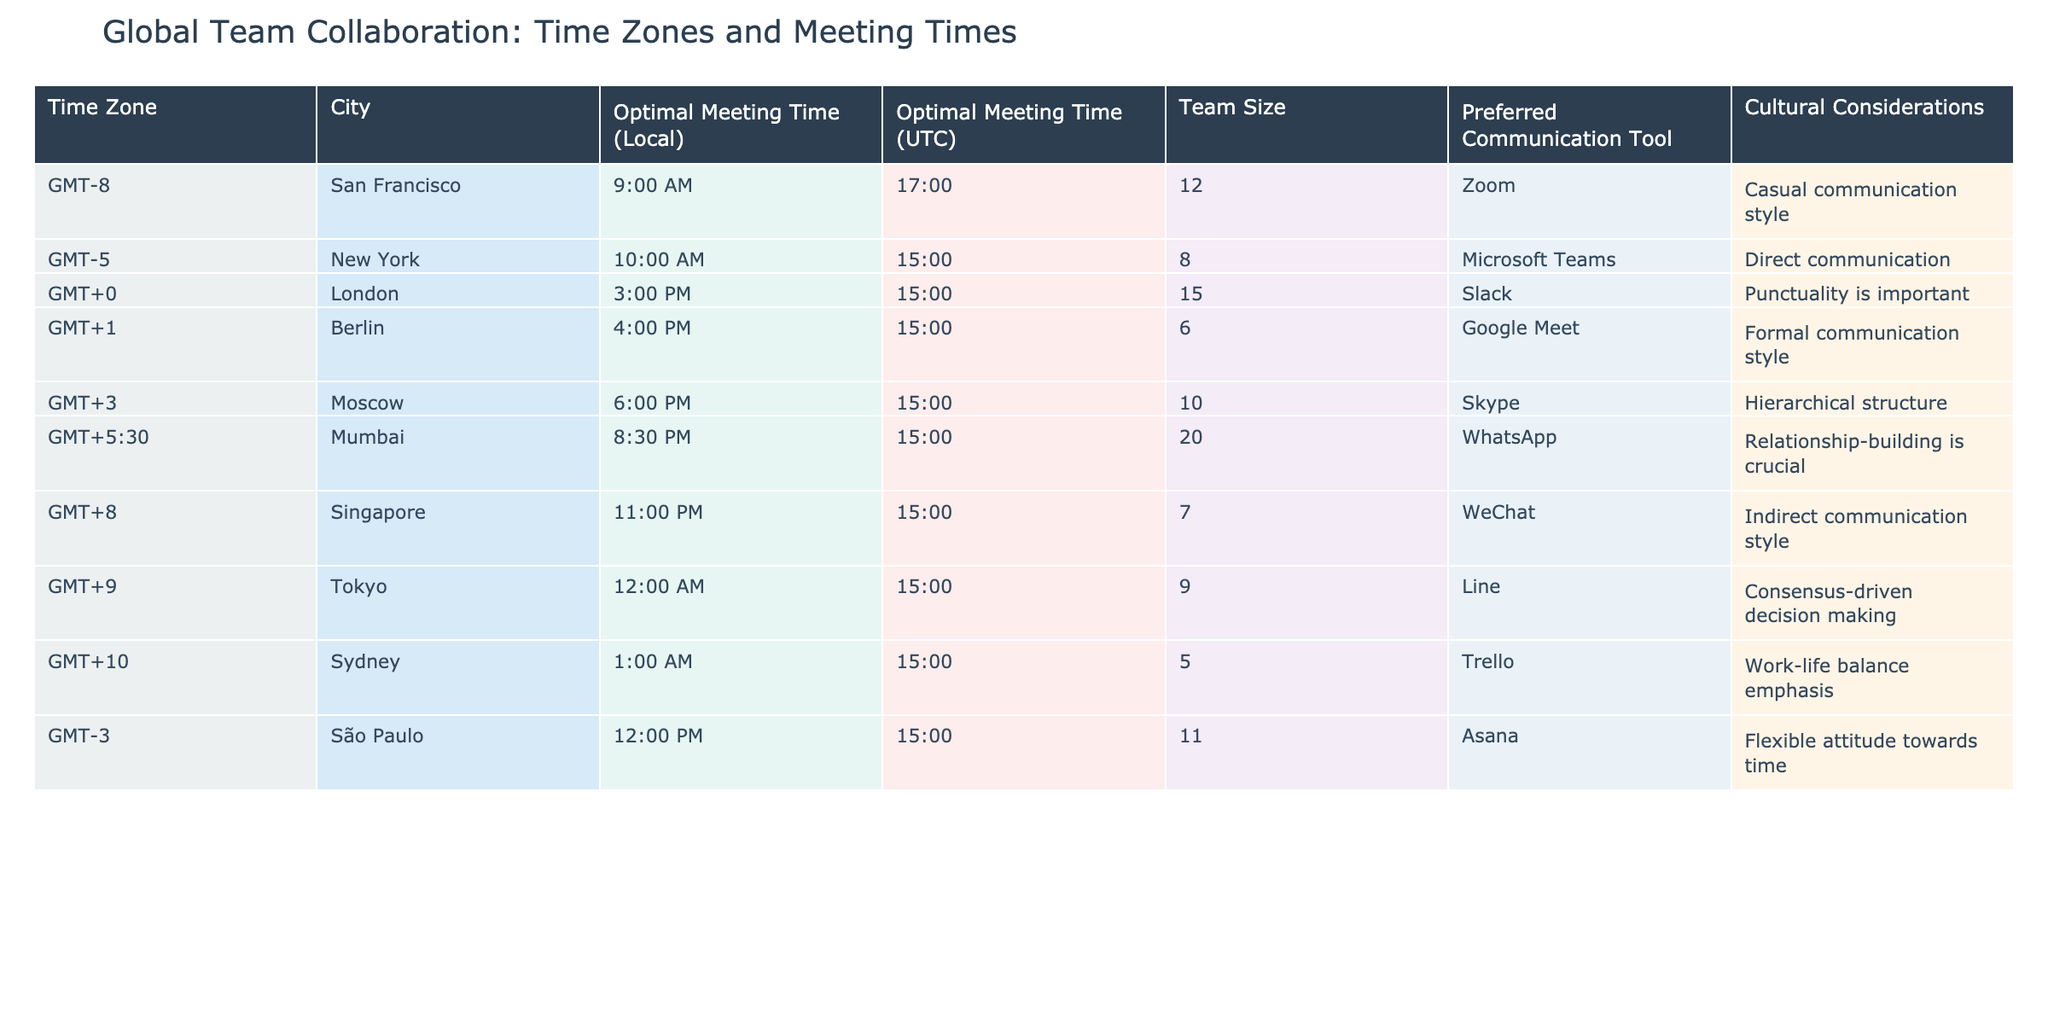What is the optimal meeting time for New York in UTC? The table indicates that the optimal meeting time for New York, which is in GMT-5, is 10:00 AM local time. To convert this to UTC, we need to add 5 hours, making it 15:00 UTC.
Answer: 15:00 Which city has the largest team size? By examining the 'Team Size' column, we see that Mumbai has the largest team size of 20 members compared to other cities listed.
Answer: Mumbai Is there a city where the optimal meeting time is at midnight? Looking through the 'Optimal Meeting Time (Local)' column, Tokyo shows the time as 12:00 AM, which indicates that it is indeed a midnight meeting time.
Answer: Yes Calculate the average team size across all cities. We can find the average by adding all team sizes together: (12 + 8 + 15 + 6 + 10 + 20 + 7 + 9 + 5 + 11) =  93. There are 10 cities, so dividing 93 by 10 gives us an average of 9.3.
Answer: 9.3 What preferred communication tool is used in São Paulo? According to the table, São Paulo has Asana listed as its preferred communication tool.
Answer: Asana Which city prefers a casual communication style? Referring to the 'Cultural Considerations' column, San Francisco prefers a casual communication style.
Answer: San Francisco Are there more cities with a formal communication style compared to informal communication? From the table, the cities with a formal communication style are Berlin and Moscow. The cities with an informal style are San Francisco and São Paulo. Since there are two formal cities and two informal cities, the answer is no, they are equal.
Answer: No What is the difference in team sizes between Moscow and Sydney? Moscow has a team size of 10, and Sydney has a team size of 5. The difference between them is 10 - 5 = 5.
Answer: 5 Which city has the latest optimal meeting time? By looking at the 'Optimal Meeting Time (Local)' column, Singapore has the latest optimal meeting time at 11:00 PM.
Answer: Singapore Is the optimal meeting time for Mumbai the same as for London? The optimal meeting time for Mumbai is 8:30 PM, while for London it is 3:00 PM; therefore, they are not the same.
Answer: No 